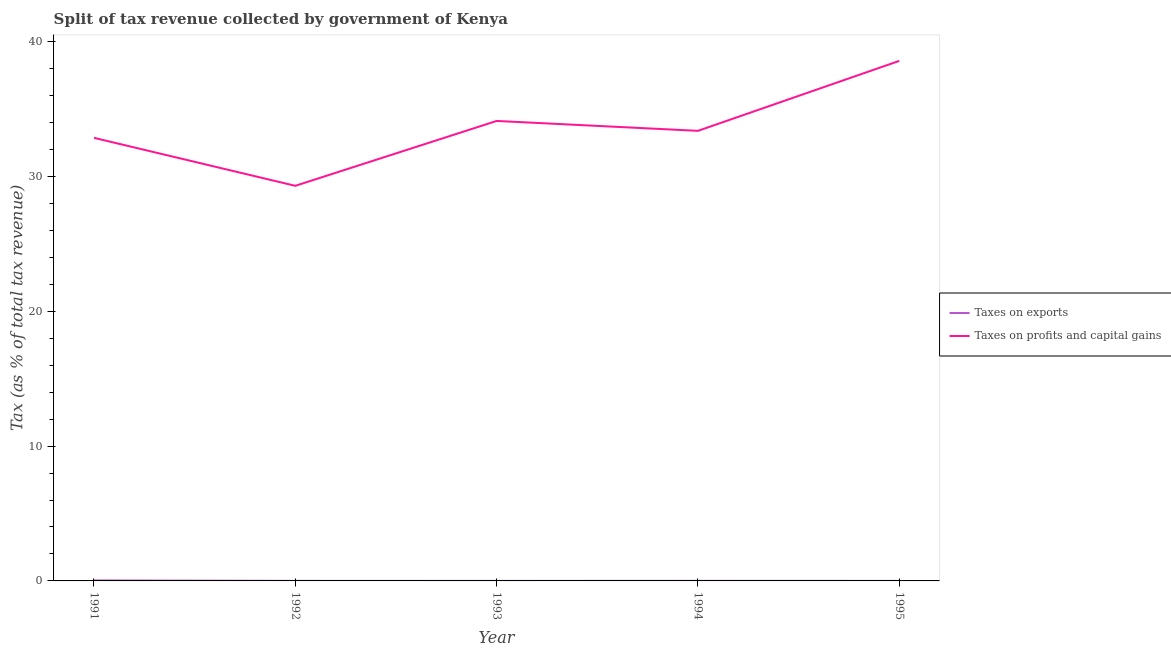How many different coloured lines are there?
Your answer should be very brief. 2. What is the percentage of revenue obtained from taxes on exports in 1991?
Keep it short and to the point. 0.04. Across all years, what is the maximum percentage of revenue obtained from taxes on exports?
Make the answer very short. 0.04. Across all years, what is the minimum percentage of revenue obtained from taxes on exports?
Offer a very short reply. 0. In which year was the percentage of revenue obtained from taxes on exports maximum?
Keep it short and to the point. 1991. In which year was the percentage of revenue obtained from taxes on exports minimum?
Keep it short and to the point. 1993. What is the total percentage of revenue obtained from taxes on profits and capital gains in the graph?
Your answer should be compact. 168.19. What is the difference between the percentage of revenue obtained from taxes on profits and capital gains in 1993 and that in 1994?
Keep it short and to the point. 0.73. What is the difference between the percentage of revenue obtained from taxes on exports in 1991 and the percentage of revenue obtained from taxes on profits and capital gains in 1995?
Provide a short and direct response. -38.52. What is the average percentage of revenue obtained from taxes on exports per year?
Your response must be concise. 0.01. In the year 1994, what is the difference between the percentage of revenue obtained from taxes on exports and percentage of revenue obtained from taxes on profits and capital gains?
Provide a short and direct response. -33.37. In how many years, is the percentage of revenue obtained from taxes on exports greater than 38 %?
Keep it short and to the point. 0. What is the ratio of the percentage of revenue obtained from taxes on exports in 1991 to that in 1994?
Your answer should be compact. 5.68. Is the percentage of revenue obtained from taxes on exports in 1993 less than that in 1994?
Offer a very short reply. Yes. Is the difference between the percentage of revenue obtained from taxes on exports in 1991 and 1995 greater than the difference between the percentage of revenue obtained from taxes on profits and capital gains in 1991 and 1995?
Give a very brief answer. Yes. What is the difference between the highest and the second highest percentage of revenue obtained from taxes on exports?
Make the answer very short. 0.03. What is the difference between the highest and the lowest percentage of revenue obtained from taxes on exports?
Your response must be concise. 0.04. In how many years, is the percentage of revenue obtained from taxes on profits and capital gains greater than the average percentage of revenue obtained from taxes on profits and capital gains taken over all years?
Your answer should be very brief. 2. How many lines are there?
Ensure brevity in your answer.  2. How many years are there in the graph?
Offer a very short reply. 5. What is the difference between two consecutive major ticks on the Y-axis?
Provide a short and direct response. 10. Are the values on the major ticks of Y-axis written in scientific E-notation?
Provide a short and direct response. No. How many legend labels are there?
Give a very brief answer. 2. How are the legend labels stacked?
Give a very brief answer. Vertical. What is the title of the graph?
Offer a very short reply. Split of tax revenue collected by government of Kenya. Does "National Visitors" appear as one of the legend labels in the graph?
Offer a terse response. No. What is the label or title of the Y-axis?
Ensure brevity in your answer.  Tax (as % of total tax revenue). What is the Tax (as % of total tax revenue) of Taxes on exports in 1991?
Ensure brevity in your answer.  0.04. What is the Tax (as % of total tax revenue) in Taxes on profits and capital gains in 1991?
Make the answer very short. 32.85. What is the Tax (as % of total tax revenue) in Taxes on exports in 1992?
Your answer should be very brief. 0. What is the Tax (as % of total tax revenue) of Taxes on profits and capital gains in 1992?
Keep it short and to the point. 29.3. What is the Tax (as % of total tax revenue) in Taxes on exports in 1993?
Give a very brief answer. 0. What is the Tax (as % of total tax revenue) in Taxes on profits and capital gains in 1993?
Make the answer very short. 34.11. What is the Tax (as % of total tax revenue) in Taxes on exports in 1994?
Give a very brief answer. 0.01. What is the Tax (as % of total tax revenue) of Taxes on profits and capital gains in 1994?
Your response must be concise. 33.37. What is the Tax (as % of total tax revenue) of Taxes on exports in 1995?
Give a very brief answer. 0. What is the Tax (as % of total tax revenue) in Taxes on profits and capital gains in 1995?
Ensure brevity in your answer.  38.56. Across all years, what is the maximum Tax (as % of total tax revenue) in Taxes on exports?
Provide a succinct answer. 0.04. Across all years, what is the maximum Tax (as % of total tax revenue) of Taxes on profits and capital gains?
Your response must be concise. 38.56. Across all years, what is the minimum Tax (as % of total tax revenue) in Taxes on exports?
Give a very brief answer. 0. Across all years, what is the minimum Tax (as % of total tax revenue) of Taxes on profits and capital gains?
Provide a succinct answer. 29.3. What is the total Tax (as % of total tax revenue) of Taxes on exports in the graph?
Offer a very short reply. 0.05. What is the total Tax (as % of total tax revenue) of Taxes on profits and capital gains in the graph?
Keep it short and to the point. 168.19. What is the difference between the Tax (as % of total tax revenue) in Taxes on exports in 1991 and that in 1992?
Your response must be concise. 0.03. What is the difference between the Tax (as % of total tax revenue) of Taxes on profits and capital gains in 1991 and that in 1992?
Ensure brevity in your answer.  3.56. What is the difference between the Tax (as % of total tax revenue) of Taxes on exports in 1991 and that in 1993?
Ensure brevity in your answer.  0.04. What is the difference between the Tax (as % of total tax revenue) of Taxes on profits and capital gains in 1991 and that in 1993?
Your response must be concise. -1.25. What is the difference between the Tax (as % of total tax revenue) of Taxes on exports in 1991 and that in 1994?
Offer a very short reply. 0.03. What is the difference between the Tax (as % of total tax revenue) in Taxes on profits and capital gains in 1991 and that in 1994?
Make the answer very short. -0.52. What is the difference between the Tax (as % of total tax revenue) of Taxes on exports in 1991 and that in 1995?
Give a very brief answer. 0.03. What is the difference between the Tax (as % of total tax revenue) of Taxes on profits and capital gains in 1991 and that in 1995?
Provide a short and direct response. -5.71. What is the difference between the Tax (as % of total tax revenue) of Taxes on exports in 1992 and that in 1993?
Your answer should be compact. 0. What is the difference between the Tax (as % of total tax revenue) in Taxes on profits and capital gains in 1992 and that in 1993?
Give a very brief answer. -4.81. What is the difference between the Tax (as % of total tax revenue) of Taxes on exports in 1992 and that in 1994?
Your answer should be very brief. -0. What is the difference between the Tax (as % of total tax revenue) of Taxes on profits and capital gains in 1992 and that in 1994?
Ensure brevity in your answer.  -4.08. What is the difference between the Tax (as % of total tax revenue) in Taxes on exports in 1992 and that in 1995?
Ensure brevity in your answer.  0. What is the difference between the Tax (as % of total tax revenue) of Taxes on profits and capital gains in 1992 and that in 1995?
Make the answer very short. -9.26. What is the difference between the Tax (as % of total tax revenue) of Taxes on exports in 1993 and that in 1994?
Ensure brevity in your answer.  -0. What is the difference between the Tax (as % of total tax revenue) in Taxes on profits and capital gains in 1993 and that in 1994?
Ensure brevity in your answer.  0.73. What is the difference between the Tax (as % of total tax revenue) in Taxes on exports in 1993 and that in 1995?
Give a very brief answer. -0. What is the difference between the Tax (as % of total tax revenue) of Taxes on profits and capital gains in 1993 and that in 1995?
Ensure brevity in your answer.  -4.45. What is the difference between the Tax (as % of total tax revenue) in Taxes on exports in 1994 and that in 1995?
Give a very brief answer. 0. What is the difference between the Tax (as % of total tax revenue) of Taxes on profits and capital gains in 1994 and that in 1995?
Your response must be concise. -5.19. What is the difference between the Tax (as % of total tax revenue) of Taxes on exports in 1991 and the Tax (as % of total tax revenue) of Taxes on profits and capital gains in 1992?
Provide a short and direct response. -29.26. What is the difference between the Tax (as % of total tax revenue) in Taxes on exports in 1991 and the Tax (as % of total tax revenue) in Taxes on profits and capital gains in 1993?
Your response must be concise. -34.07. What is the difference between the Tax (as % of total tax revenue) of Taxes on exports in 1991 and the Tax (as % of total tax revenue) of Taxes on profits and capital gains in 1994?
Offer a terse response. -33.33. What is the difference between the Tax (as % of total tax revenue) of Taxes on exports in 1991 and the Tax (as % of total tax revenue) of Taxes on profits and capital gains in 1995?
Ensure brevity in your answer.  -38.52. What is the difference between the Tax (as % of total tax revenue) in Taxes on exports in 1992 and the Tax (as % of total tax revenue) in Taxes on profits and capital gains in 1993?
Your answer should be compact. -34.1. What is the difference between the Tax (as % of total tax revenue) of Taxes on exports in 1992 and the Tax (as % of total tax revenue) of Taxes on profits and capital gains in 1994?
Give a very brief answer. -33.37. What is the difference between the Tax (as % of total tax revenue) in Taxes on exports in 1992 and the Tax (as % of total tax revenue) in Taxes on profits and capital gains in 1995?
Ensure brevity in your answer.  -38.56. What is the difference between the Tax (as % of total tax revenue) of Taxes on exports in 1993 and the Tax (as % of total tax revenue) of Taxes on profits and capital gains in 1994?
Your answer should be compact. -33.37. What is the difference between the Tax (as % of total tax revenue) in Taxes on exports in 1993 and the Tax (as % of total tax revenue) in Taxes on profits and capital gains in 1995?
Ensure brevity in your answer.  -38.56. What is the difference between the Tax (as % of total tax revenue) of Taxes on exports in 1994 and the Tax (as % of total tax revenue) of Taxes on profits and capital gains in 1995?
Your answer should be compact. -38.55. What is the average Tax (as % of total tax revenue) of Taxes on exports per year?
Provide a short and direct response. 0.01. What is the average Tax (as % of total tax revenue) in Taxes on profits and capital gains per year?
Offer a terse response. 33.64. In the year 1991, what is the difference between the Tax (as % of total tax revenue) in Taxes on exports and Tax (as % of total tax revenue) in Taxes on profits and capital gains?
Make the answer very short. -32.82. In the year 1992, what is the difference between the Tax (as % of total tax revenue) of Taxes on exports and Tax (as % of total tax revenue) of Taxes on profits and capital gains?
Offer a very short reply. -29.29. In the year 1993, what is the difference between the Tax (as % of total tax revenue) in Taxes on exports and Tax (as % of total tax revenue) in Taxes on profits and capital gains?
Your answer should be compact. -34.1. In the year 1994, what is the difference between the Tax (as % of total tax revenue) of Taxes on exports and Tax (as % of total tax revenue) of Taxes on profits and capital gains?
Make the answer very short. -33.37. In the year 1995, what is the difference between the Tax (as % of total tax revenue) of Taxes on exports and Tax (as % of total tax revenue) of Taxes on profits and capital gains?
Provide a succinct answer. -38.56. What is the ratio of the Tax (as % of total tax revenue) in Taxes on exports in 1991 to that in 1992?
Offer a terse response. 9.24. What is the ratio of the Tax (as % of total tax revenue) of Taxes on profits and capital gains in 1991 to that in 1992?
Give a very brief answer. 1.12. What is the ratio of the Tax (as % of total tax revenue) of Taxes on exports in 1991 to that in 1993?
Provide a succinct answer. 18.95. What is the ratio of the Tax (as % of total tax revenue) in Taxes on profits and capital gains in 1991 to that in 1993?
Keep it short and to the point. 0.96. What is the ratio of the Tax (as % of total tax revenue) in Taxes on exports in 1991 to that in 1994?
Your answer should be compact. 5.68. What is the ratio of the Tax (as % of total tax revenue) in Taxes on profits and capital gains in 1991 to that in 1994?
Offer a terse response. 0.98. What is the ratio of the Tax (as % of total tax revenue) of Taxes on exports in 1991 to that in 1995?
Your answer should be very brief. 12.06. What is the ratio of the Tax (as % of total tax revenue) in Taxes on profits and capital gains in 1991 to that in 1995?
Offer a terse response. 0.85. What is the ratio of the Tax (as % of total tax revenue) in Taxes on exports in 1992 to that in 1993?
Keep it short and to the point. 2.05. What is the ratio of the Tax (as % of total tax revenue) of Taxes on profits and capital gains in 1992 to that in 1993?
Keep it short and to the point. 0.86. What is the ratio of the Tax (as % of total tax revenue) in Taxes on exports in 1992 to that in 1994?
Offer a terse response. 0.61. What is the ratio of the Tax (as % of total tax revenue) of Taxes on profits and capital gains in 1992 to that in 1994?
Make the answer very short. 0.88. What is the ratio of the Tax (as % of total tax revenue) of Taxes on exports in 1992 to that in 1995?
Your response must be concise. 1.31. What is the ratio of the Tax (as % of total tax revenue) in Taxes on profits and capital gains in 1992 to that in 1995?
Provide a short and direct response. 0.76. What is the ratio of the Tax (as % of total tax revenue) in Taxes on exports in 1993 to that in 1994?
Make the answer very short. 0.3. What is the ratio of the Tax (as % of total tax revenue) in Taxes on profits and capital gains in 1993 to that in 1994?
Your answer should be very brief. 1.02. What is the ratio of the Tax (as % of total tax revenue) of Taxes on exports in 1993 to that in 1995?
Keep it short and to the point. 0.64. What is the ratio of the Tax (as % of total tax revenue) in Taxes on profits and capital gains in 1993 to that in 1995?
Offer a very short reply. 0.88. What is the ratio of the Tax (as % of total tax revenue) in Taxes on exports in 1994 to that in 1995?
Provide a short and direct response. 2.12. What is the ratio of the Tax (as % of total tax revenue) of Taxes on profits and capital gains in 1994 to that in 1995?
Give a very brief answer. 0.87. What is the difference between the highest and the second highest Tax (as % of total tax revenue) in Taxes on exports?
Your response must be concise. 0.03. What is the difference between the highest and the second highest Tax (as % of total tax revenue) in Taxes on profits and capital gains?
Keep it short and to the point. 4.45. What is the difference between the highest and the lowest Tax (as % of total tax revenue) of Taxes on exports?
Provide a succinct answer. 0.04. What is the difference between the highest and the lowest Tax (as % of total tax revenue) in Taxes on profits and capital gains?
Your answer should be compact. 9.26. 